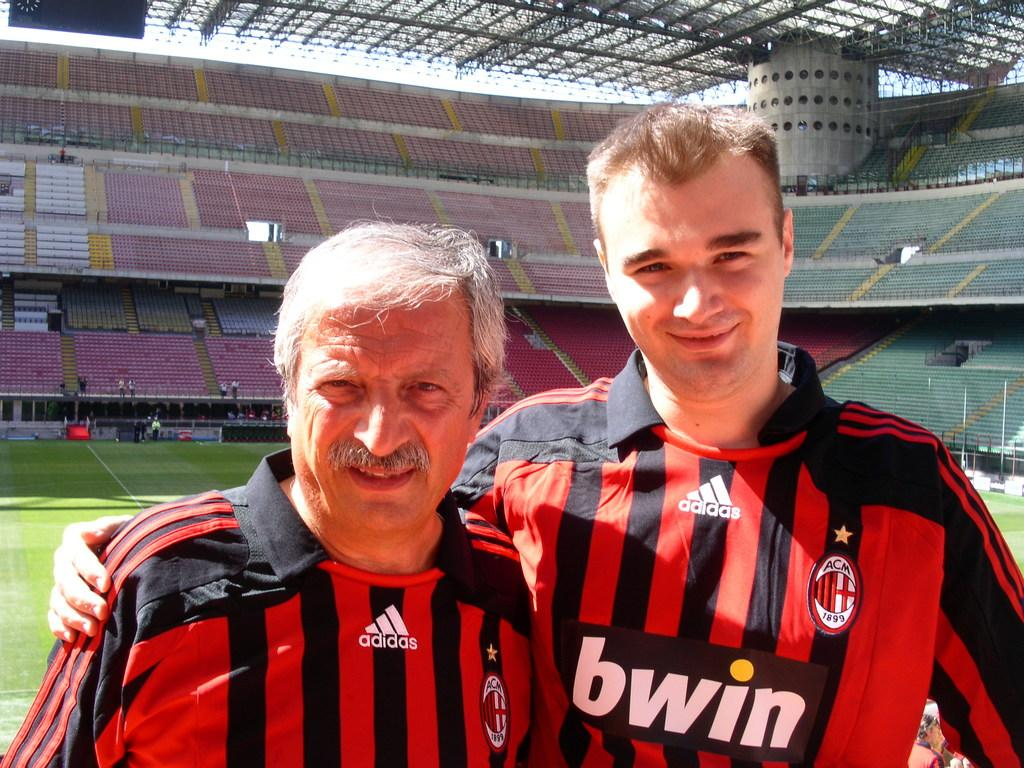How many people are in the foreground of the image? There are two people standing in the foreground of the image. What can be seen in the background of the image? There are stands in the background of the image. What is at the top of the image? There are rods at the top of the image. What type of natural environment is visible in the image? There is grass visible in the image. What type of waves can be seen crashing on the shore in the image? There is no shore or waves present in the image; it features two people, stands, rods, and grass. 